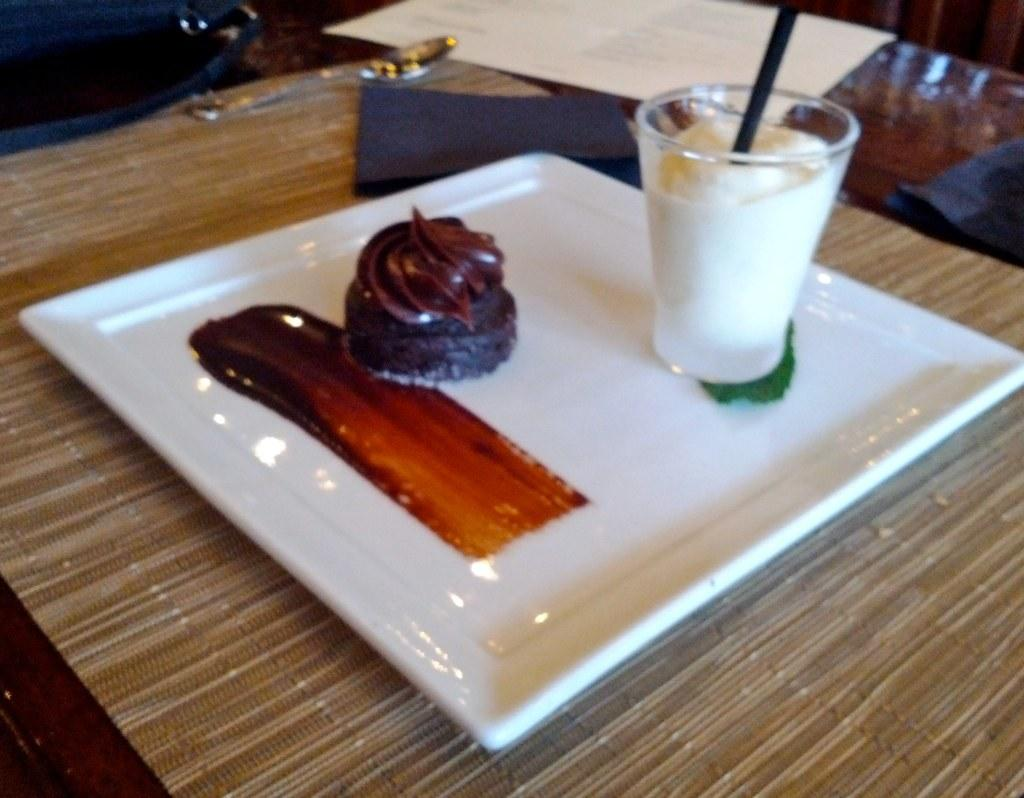What color is the plate that holds the food in the image? The plate is white. Where is the plate with food located in the image? The plate is placed on a table. What else can be seen on the table in the image? There is a glass on the right side of the image. What is the color of the food on the plate? The food is in brown color. What type of soap is being used to clean the acoustics in the image? There is no soap or acoustics present in the image; it features a plate with food on a table and a glass on the right side. 